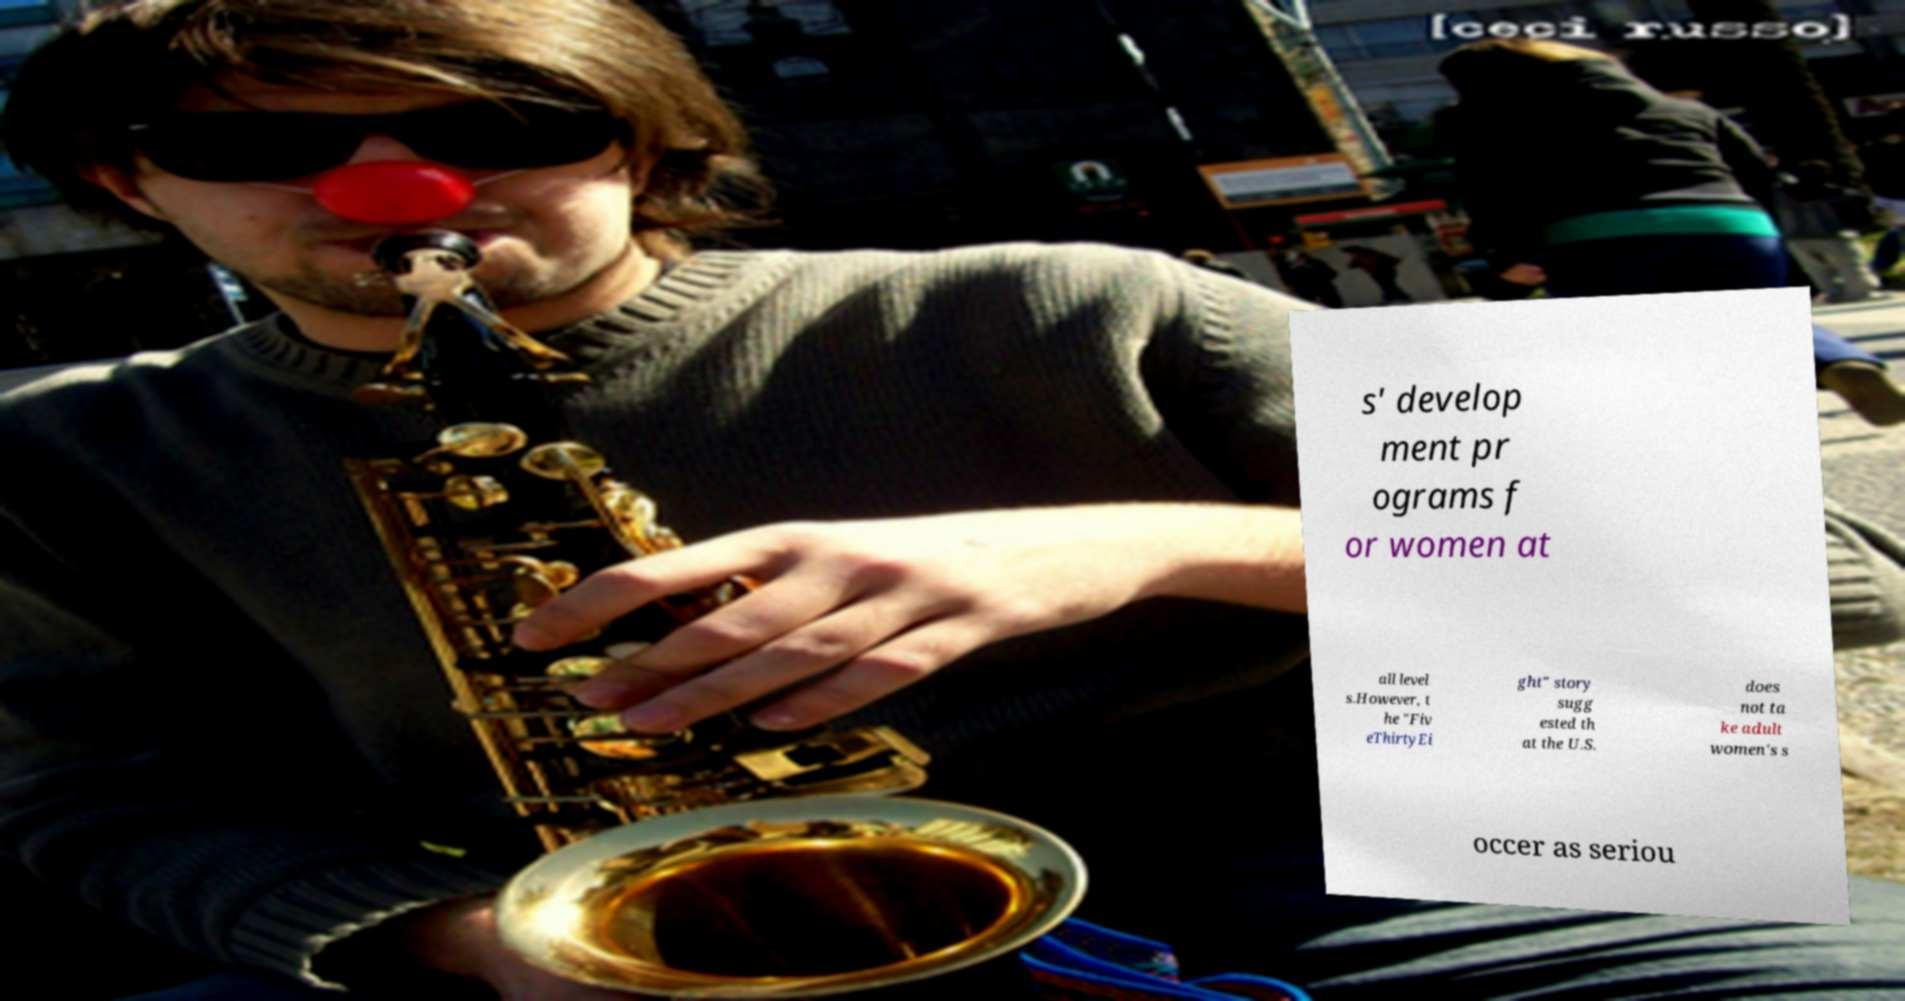What messages or text are displayed in this image? I need them in a readable, typed format. s' develop ment pr ograms f or women at all level s.However, t he "Fiv eThirtyEi ght" story sugg ested th at the U.S. does not ta ke adult women's s occer as seriou 